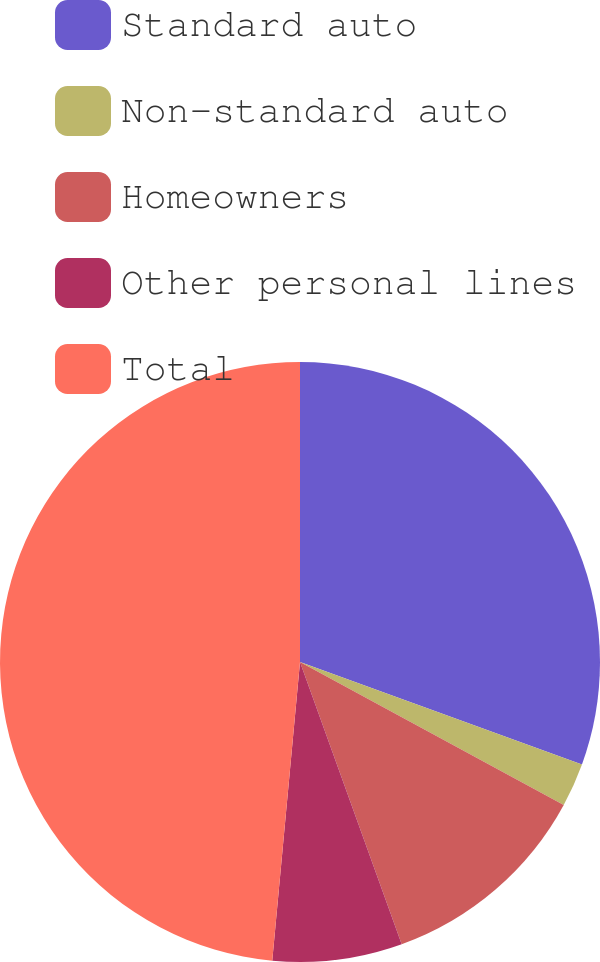<chart> <loc_0><loc_0><loc_500><loc_500><pie_chart><fcel>Standard auto<fcel>Non-standard auto<fcel>Homeowners<fcel>Other personal lines<fcel>Total<nl><fcel>30.55%<fcel>2.36%<fcel>11.59%<fcel>6.98%<fcel>48.53%<nl></chart> 